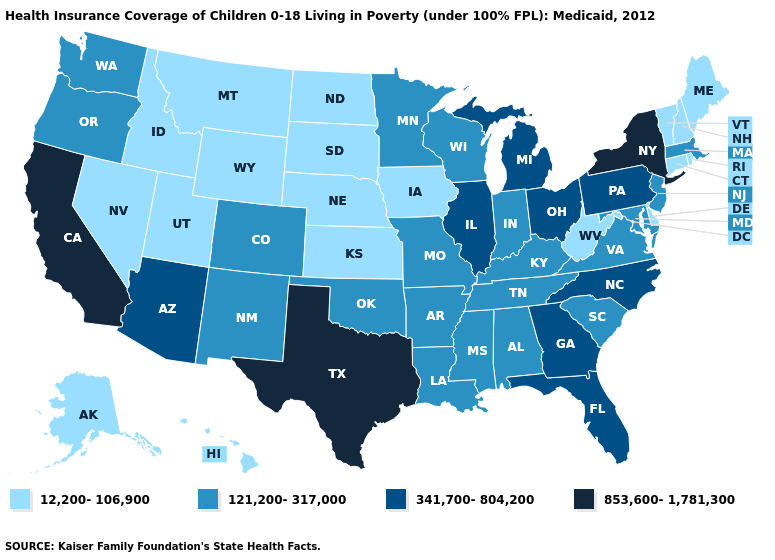What is the value of Massachusetts?
Quick response, please. 121,200-317,000. What is the highest value in states that border Montana?
Quick response, please. 12,200-106,900. Name the states that have a value in the range 853,600-1,781,300?
Answer briefly. California, New York, Texas. Name the states that have a value in the range 853,600-1,781,300?
Quick response, please. California, New York, Texas. Among the states that border Iowa , which have the lowest value?
Write a very short answer. Nebraska, South Dakota. What is the highest value in states that border Vermont?
Write a very short answer. 853,600-1,781,300. What is the highest value in states that border Idaho?
Concise answer only. 121,200-317,000. Name the states that have a value in the range 853,600-1,781,300?
Give a very brief answer. California, New York, Texas. What is the value of Pennsylvania?
Concise answer only. 341,700-804,200. Among the states that border Wisconsin , which have the lowest value?
Be succinct. Iowa. What is the highest value in the USA?
Answer briefly. 853,600-1,781,300. What is the value of Wyoming?
Be succinct. 12,200-106,900. What is the value of New Mexico?
Keep it brief. 121,200-317,000. Name the states that have a value in the range 853,600-1,781,300?
Give a very brief answer. California, New York, Texas. What is the value of Texas?
Short answer required. 853,600-1,781,300. 